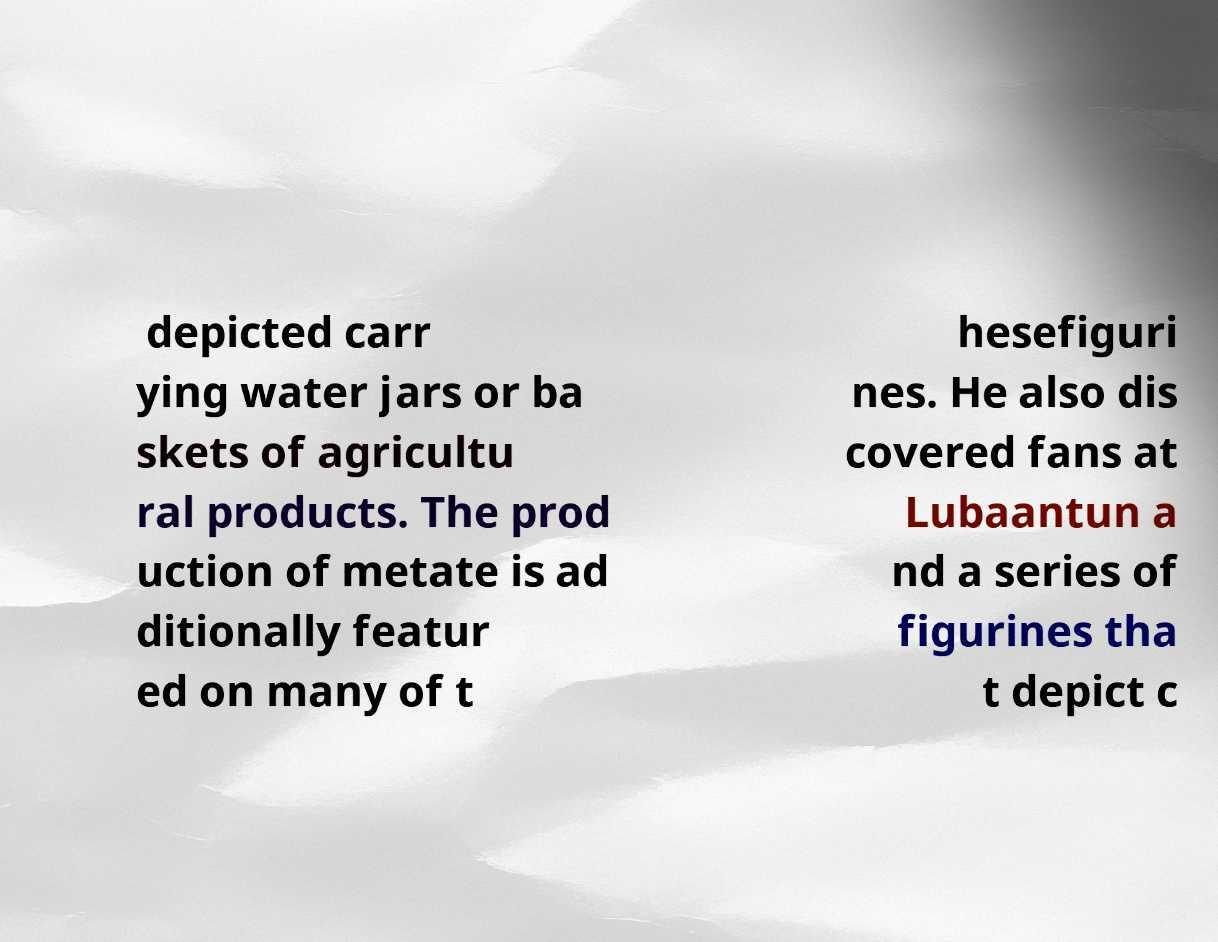What messages or text are displayed in this image? I need them in a readable, typed format. depicted carr ying water jars or ba skets of agricultu ral products. The prod uction of metate is ad ditionally featur ed on many of t hesefiguri nes. He also dis covered fans at Lubaantun a nd a series of figurines tha t depict c 